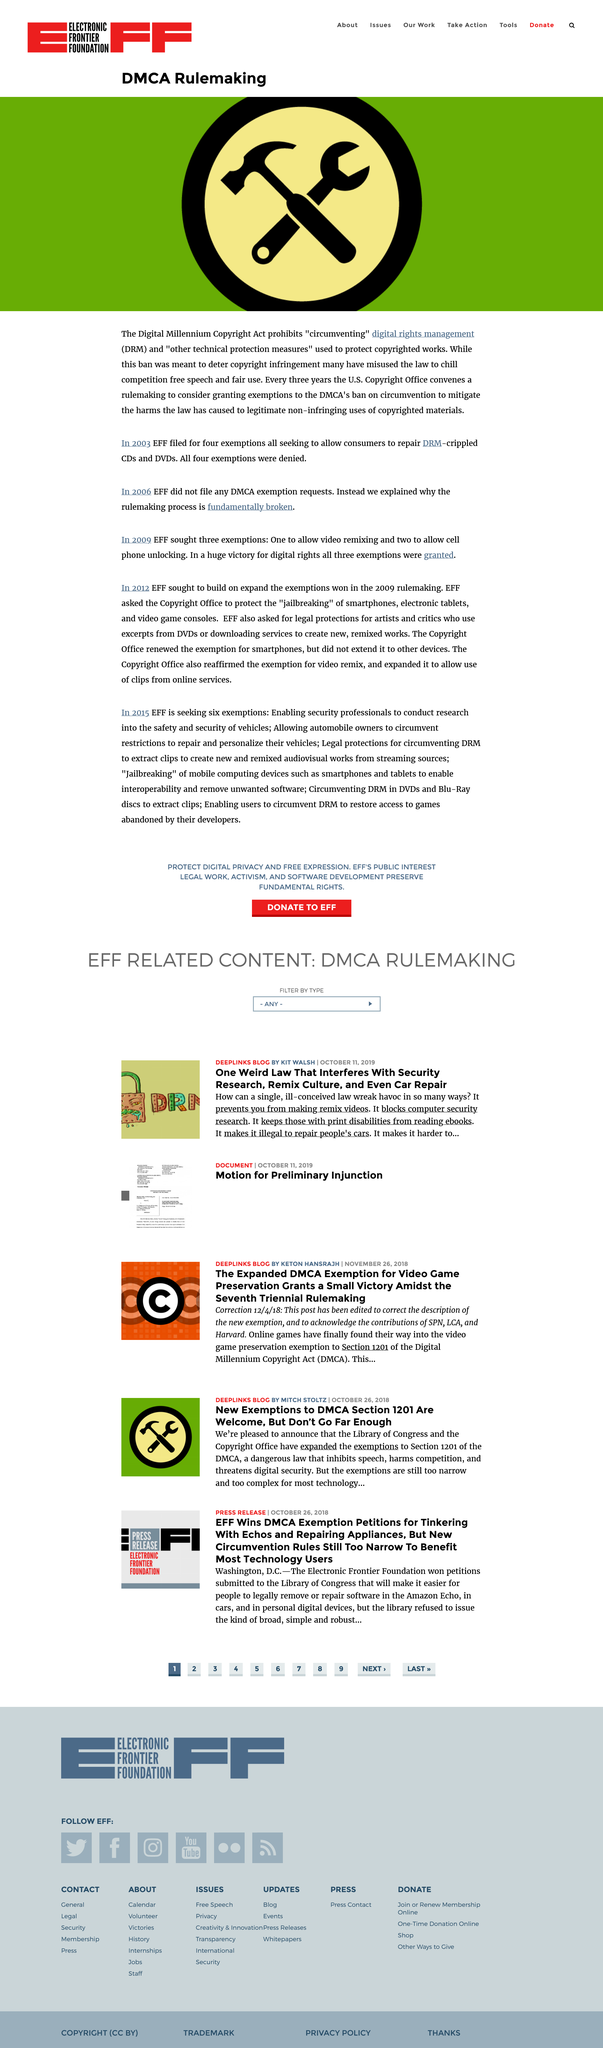Mention a couple of crucial points in this snapshot. In 2003, the four exemptions filed by the Electronic Frontier Foundation (EFF) were denied. In the year 2003, the Electronic Frontier Foundation (EFF) filed for four exemptions to allow consumers to repair Digital Rights Management (DRM)-crippled Compact Disc (CD) and Digital Versatile Disc (DVD) media. The U.S. Copyright Office conducts a rulemaking every three years to deliberate on the possibility of granting exemptions to the Digital Millennium Copyright Act's prohibition on the circumvention of copyrighted works. 